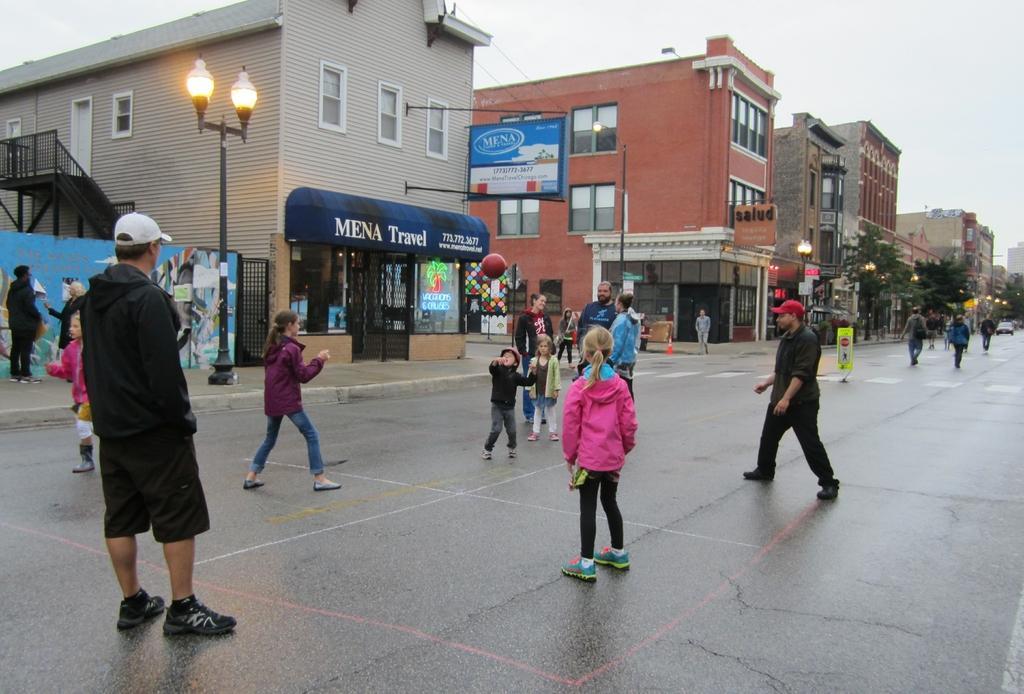Describe this image in one or two sentences. In this image we can see people, road, poles, lights, boards, ball, windows, and buildings. In the background there is sky. 